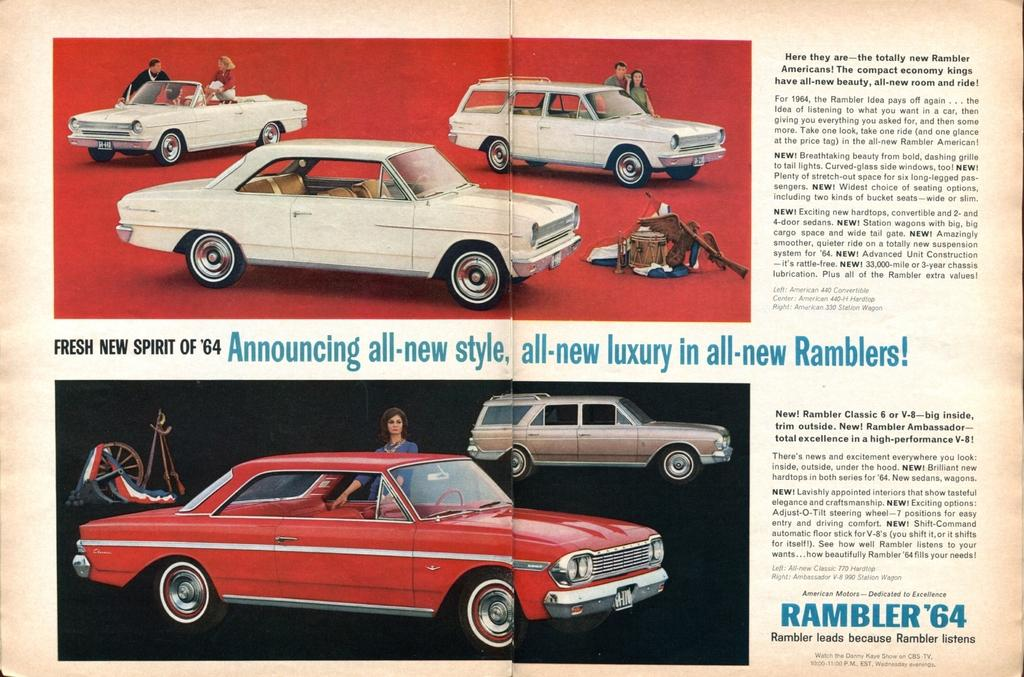What type of publication is visible in the image? There is a magazine in the image. What else can be seen in the image besides the magazine? There are vehicles and people visible in the image. What might be the purpose of the information visible in the image? The information visible in the image might be related to the vehicles or people. How many hands are visible in the image? There is no mention of hands in the provided facts, so we cannot determine how many hands are visible in the image. 